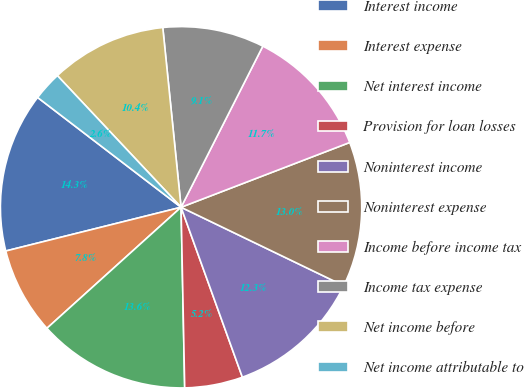Convert chart. <chart><loc_0><loc_0><loc_500><loc_500><pie_chart><fcel>Interest income<fcel>Interest expense<fcel>Net interest income<fcel>Provision for loan losses<fcel>Noninterest income<fcel>Noninterest expense<fcel>Income before income tax<fcel>Income tax expense<fcel>Net income before<fcel>Net income attributable to<nl><fcel>14.29%<fcel>7.79%<fcel>13.64%<fcel>5.19%<fcel>12.34%<fcel>12.99%<fcel>11.69%<fcel>9.09%<fcel>10.39%<fcel>2.6%<nl></chart> 